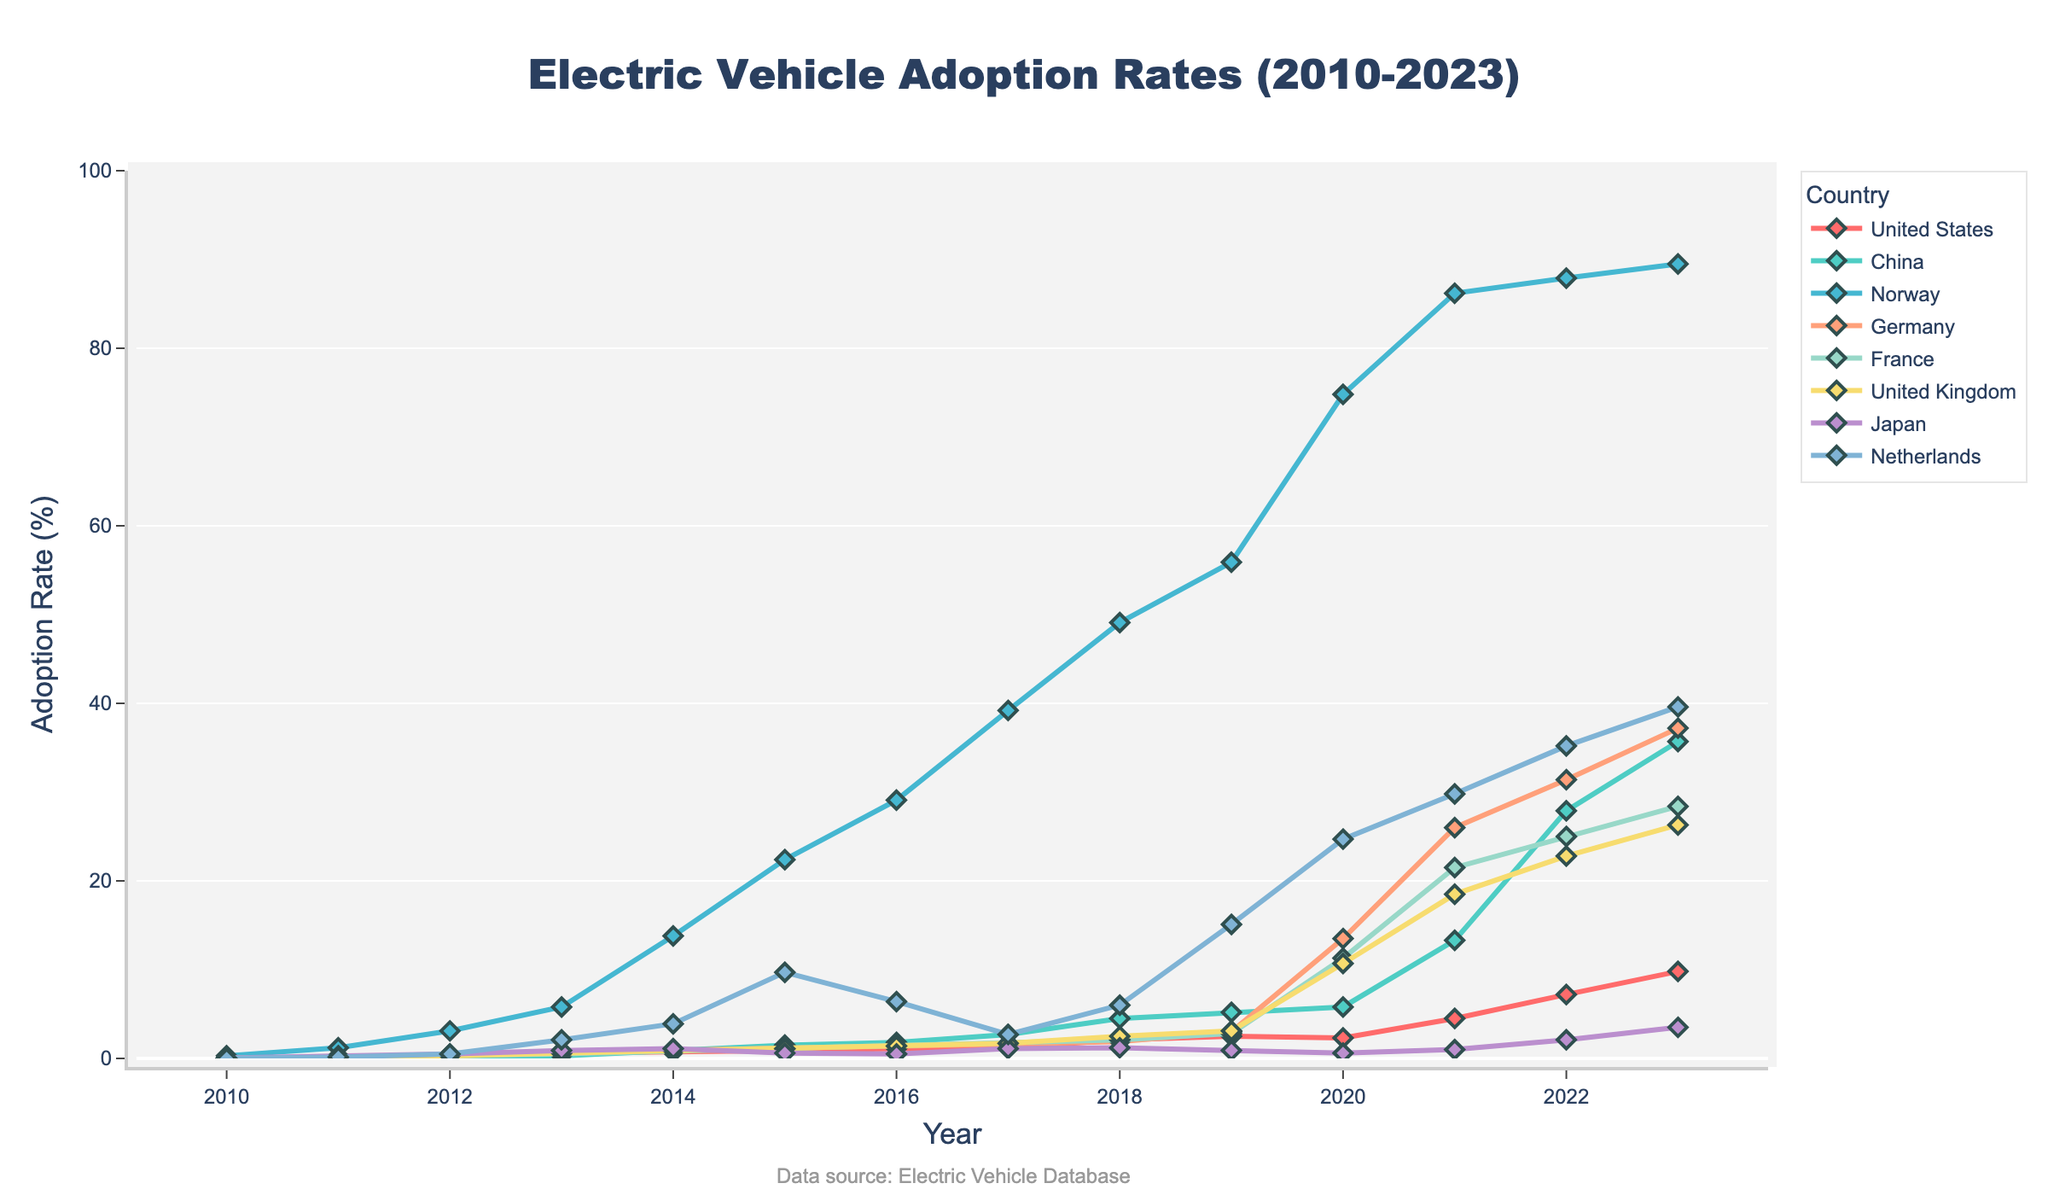What is the overall trend in electric vehicle adoption rates for Norway from 2010 to 2023? The chart shows the adoption rates for Norway starting at 0.3% in 2010 and increasing steadily over time. By 2023, the adoption rate reaches 89.5%. This indicates a continuous upward trend in electric vehicle adoption in Norway.
Answer: Increasing Which country had the highest adoption rate in 2023? By looking at the end points of the lines in the chart for the year 2023, Norway has the highest adoption rate at 89.5%.
Answer: Norway What is the difference between China and the United States in electric vehicle adoption rates in 2023? The adoption rate for China in 2023 is 35.7%, and for the United States, it is 9.8%. The difference is obtained by subtracting the United States rate from China's rate: 35.7% - 9.8% = 25.9%.
Answer: 25.9% Which country showed the most rapid increase in adoption rates between 2020 and 2021? To find the country with the most rapid increase, observe the segments for 2020 and 2021. Germany's adoption rate increases from 13.5% in 2020 to 26.0% in 2021, a difference of 12.5%, which is larger than that of any other country in that period.
Answer: Germany Which country had no decrease in adoption rates throughout the years 2010 to 2023? By examining the chart lines from 2010 to 2023 for all countries, it is seen that Norway's line shows a consistent upward trend with no decreases.
Answer: Norway In what year did the United Kingdom's adoption rate surpass 20%? By tracking the line corresponding to the United Kingdom (orange color) and finding where it first goes above 20%, it is at the point labeled 2021.
Answer: 2021 What is the average adoption rate of Japan across all presented years? Sum the adoption rates of Japan for each year and divide by the number of years: (0.05 + 0.3 + 0.5 + 0.9 + 1.1 + 0.6 + 0.5 + 1.1 + 1.2 + 0.9 + 0.6 + 1.0 + 2.1 + 3.5) / 14 = 1.071%.
Answer: 1.071% Which country displays the steepest slope in adoption rates during the period from 2018 to 2020? The steepest slope can be identified by the sharpest rise in the line segment between 2018 and 2020. Germany's adoption rate increases from 1.9% in 2018 to 13.5% in 2020, showing a steep rise of 11.6%.
Answer: Germany What is the sum of adoption rates for France and the Netherlands in 2017? France's adoption rate in 2017 is 1.7%, and the Netherlands has a rate of 2.7%. Adding these together gives 1.7% + 2.7% = 4.4%.
Answer: 4.4% How much higher was Norway's adoption rate compared to Japan's in 2023? Norway's rate in 2023 is 89.5%, and Japan's rate is 3.5%. The difference is 89.5% - 3.5% = 86.0%.
Answer: 86.0% 